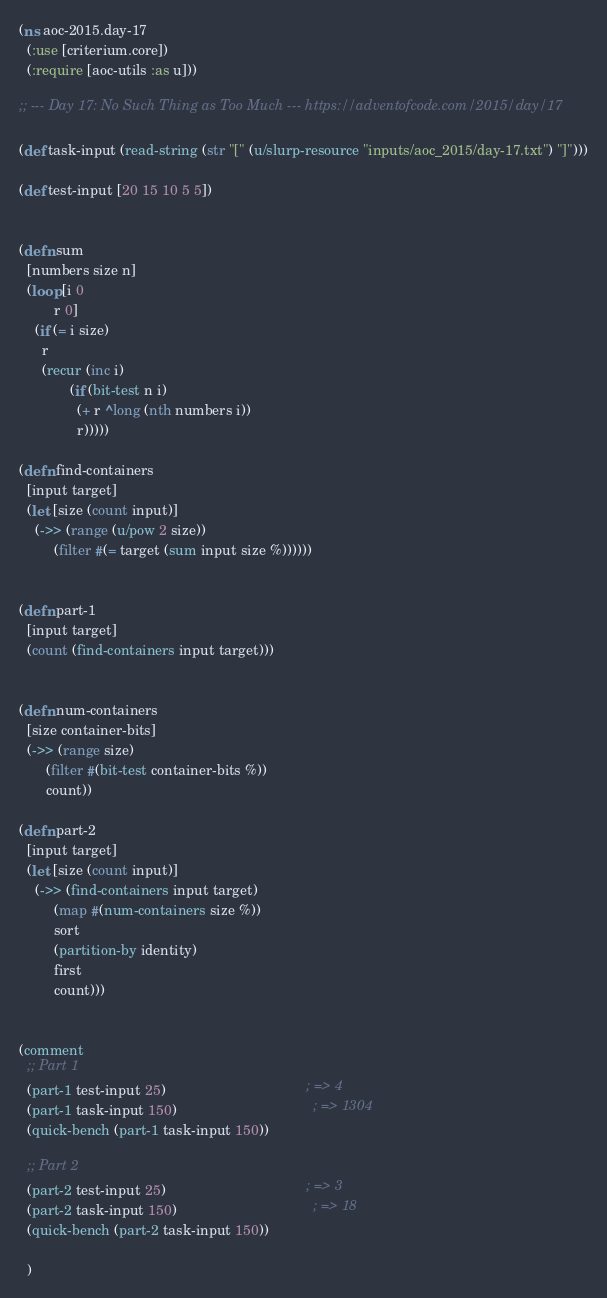Convert code to text. <code><loc_0><loc_0><loc_500><loc_500><_Clojure_>(ns aoc-2015.day-17
  (:use [criterium.core])
  (:require [aoc-utils :as u]))

;; --- Day 17: No Such Thing as Too Much --- https://adventofcode.com/2015/day/17

(def task-input (read-string (str "[" (u/slurp-resource "inputs/aoc_2015/day-17.txt") "]")))

(def test-input [20 15 10 5 5])


(defn sum
  [numbers size n]
  (loop [i 0
         r 0]
    (if (= i size)
      r
      (recur (inc i)
             (if (bit-test n i)
               (+ r ^long (nth numbers i))
               r)))))

(defn find-containers
  [input target]
  (let [size (count input)]
    (->> (range (u/pow 2 size))
         (filter #(= target (sum input size %))))))


(defn part-1
  [input target]
  (count (find-containers input target)))


(defn num-containers
  [size container-bits]
  (->> (range size)
       (filter #(bit-test container-bits %))
       count))

(defn part-2
  [input target]
  (let [size (count input)]
    (->> (find-containers input target)
         (map #(num-containers size %))
         sort
         (partition-by identity)
         first
         count)))


(comment
  ;; Part 1
  (part-1 test-input 25)                                    ; => 4
  (part-1 task-input 150)                                   ; => 1304
  (quick-bench (part-1 task-input 150))

  ;; Part 2
  (part-2 test-input 25)                                    ; => 3
  (part-2 task-input 150)                                   ; => 18
  (quick-bench (part-2 task-input 150))

  )
</code> 